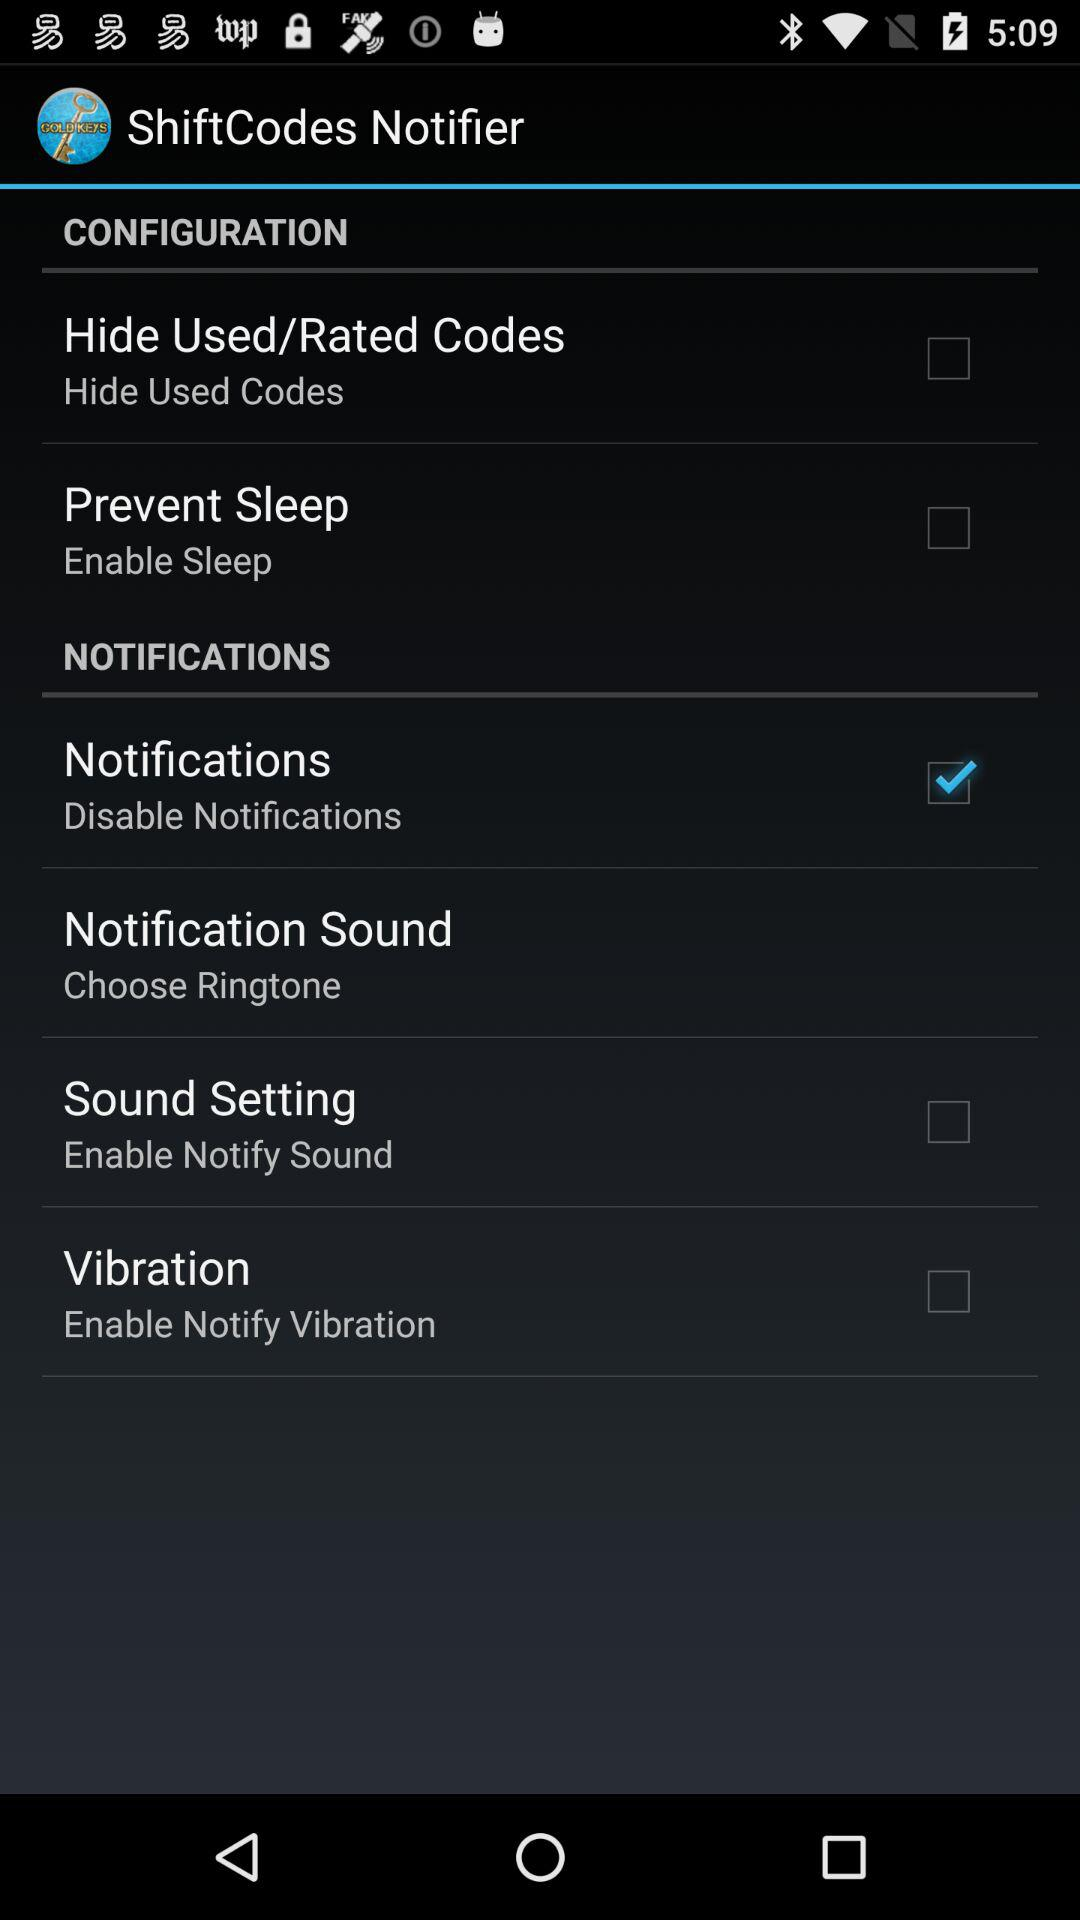Which option was selected? The selected option was "Notifications". 